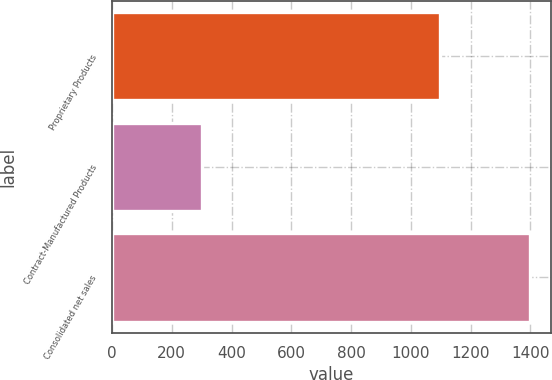Convert chart. <chart><loc_0><loc_0><loc_500><loc_500><bar_chart><fcel>Proprietary Products<fcel>Contract-Manufactured Products<fcel>Consolidated net sales<nl><fcel>1098.3<fcel>302.4<fcel>1399.8<nl></chart> 